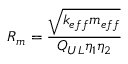Convert formula to latex. <formula><loc_0><loc_0><loc_500><loc_500>R _ { m } = \frac { \sqrt { k _ { e f f } m _ { e f f } } } { Q _ { U L } \eta _ { 1 } \eta _ { 2 } }</formula> 